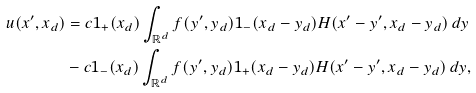Convert formula to latex. <formula><loc_0><loc_0><loc_500><loc_500>u ( x ^ { \prime } , x _ { d } ) & = c 1 _ { + } ( x _ { d } ) \int _ { \mathbb { R } ^ { d } } f ( y ^ { \prime } , y _ { d } ) 1 _ { - } ( x _ { d } - y _ { d } ) H ( x ^ { \prime } - y ^ { \prime } , x _ { d } - y _ { d } ) \, d y \\ & - c 1 _ { - } ( x _ { d } ) \int _ { \mathbb { R } ^ { d } } f ( y ^ { \prime } , y _ { d } ) 1 _ { + } ( x _ { d } - y _ { d } ) H ( x ^ { \prime } - y ^ { \prime } , x _ { d } - y _ { d } ) \, d y ,</formula> 